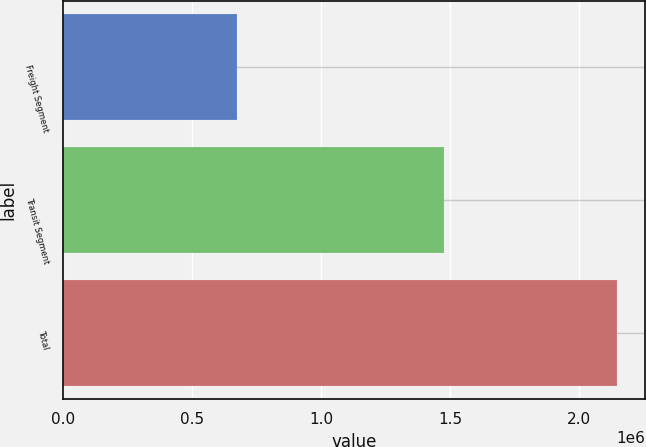<chart> <loc_0><loc_0><loc_500><loc_500><bar_chart><fcel>Freight Segment<fcel>Transit Segment<fcel>Total<nl><fcel>671910<fcel>1.47497e+06<fcel>2.14688e+06<nl></chart> 